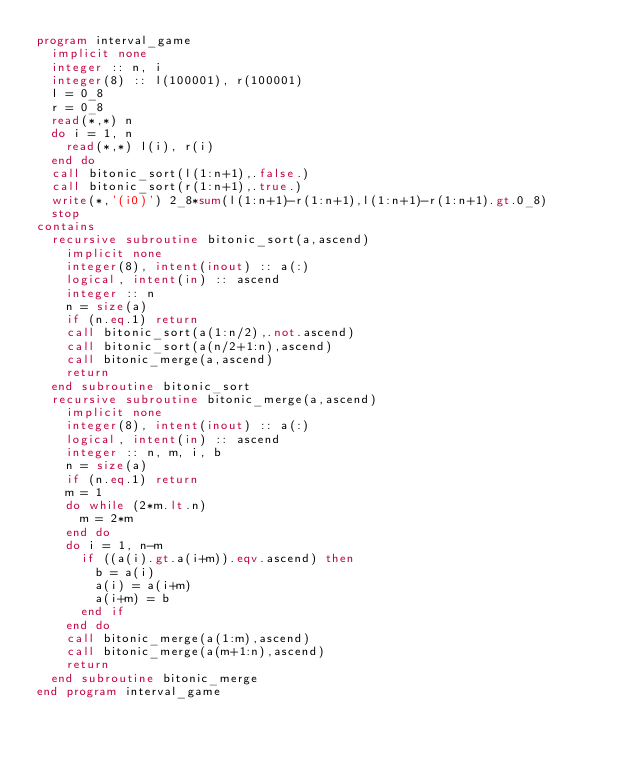<code> <loc_0><loc_0><loc_500><loc_500><_FORTRAN_>program interval_game
  implicit none
  integer :: n, i
  integer(8) :: l(100001), r(100001)
  l = 0_8
  r = 0_8
  read(*,*) n
  do i = 1, n
    read(*,*) l(i), r(i)
  end do
  call bitonic_sort(l(1:n+1),.false.)
  call bitonic_sort(r(1:n+1),.true.)
  write(*,'(i0)') 2_8*sum(l(1:n+1)-r(1:n+1),l(1:n+1)-r(1:n+1).gt.0_8)
  stop
contains
  recursive subroutine bitonic_sort(a,ascend)
    implicit none
    integer(8), intent(inout) :: a(:)
    logical, intent(in) :: ascend
    integer :: n
    n = size(a)
    if (n.eq.1) return
    call bitonic_sort(a(1:n/2),.not.ascend)
    call bitonic_sort(a(n/2+1:n),ascend)
    call bitonic_merge(a,ascend)
    return
  end subroutine bitonic_sort
  recursive subroutine bitonic_merge(a,ascend)
    implicit none
    integer(8), intent(inout) :: a(:)
    logical, intent(in) :: ascend
    integer :: n, m, i, b
    n = size(a)
    if (n.eq.1) return
    m = 1
    do while (2*m.lt.n)
      m = 2*m
    end do
    do i = 1, n-m
      if ((a(i).gt.a(i+m)).eqv.ascend) then
        b = a(i)
        a(i) = a(i+m)
        a(i+m) = b
      end if
    end do
    call bitonic_merge(a(1:m),ascend)
    call bitonic_merge(a(m+1:n),ascend)
    return
  end subroutine bitonic_merge
end program interval_game</code> 